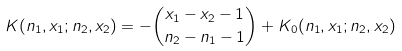<formula> <loc_0><loc_0><loc_500><loc_500>K ( n _ { 1 } , x _ { 1 } ; n _ { 2 } , x _ { 2 } ) = - \binom { x _ { 1 } - x _ { 2 } - 1 } { n _ { 2 } - n _ { 1 } - 1 } + K _ { 0 } ( n _ { 1 } , x _ { 1 } ; n _ { 2 } , x _ { 2 } )</formula> 